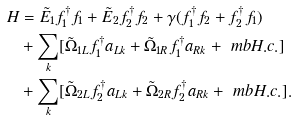<formula> <loc_0><loc_0><loc_500><loc_500>H & = \tilde { E } _ { 1 } f ^ { \dagger } _ { 1 } f _ { 1 } + \tilde { E } _ { 2 } f ^ { \dagger } _ { 2 } f _ { 2 } + \gamma ( f ^ { \dagger } _ { 1 } f _ { 2 } + f ^ { \dagger } _ { 2 } f _ { 1 } ) \\ & + \sum _ { k } [ \tilde { \Omega } _ { 1 L } f ^ { \dagger } _ { 1 } a _ { L k } + \tilde { \Omega } _ { 1 R } f ^ { \dagger } _ { 1 } a _ { R k } + \ m b { H . c . } ] \\ & + \sum _ { k } [ \tilde { \Omega } _ { 2 L } f ^ { \dagger } _ { 2 } a _ { L k } + \tilde { \Omega } _ { 2 R } f ^ { \dagger } _ { 2 } a _ { R k } + \ m b { H . c . } ] .</formula> 